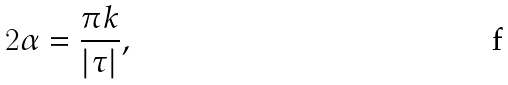Convert formula to latex. <formula><loc_0><loc_0><loc_500><loc_500>2 \alpha = \frac { \pi k } { | \tau | } ,</formula> 